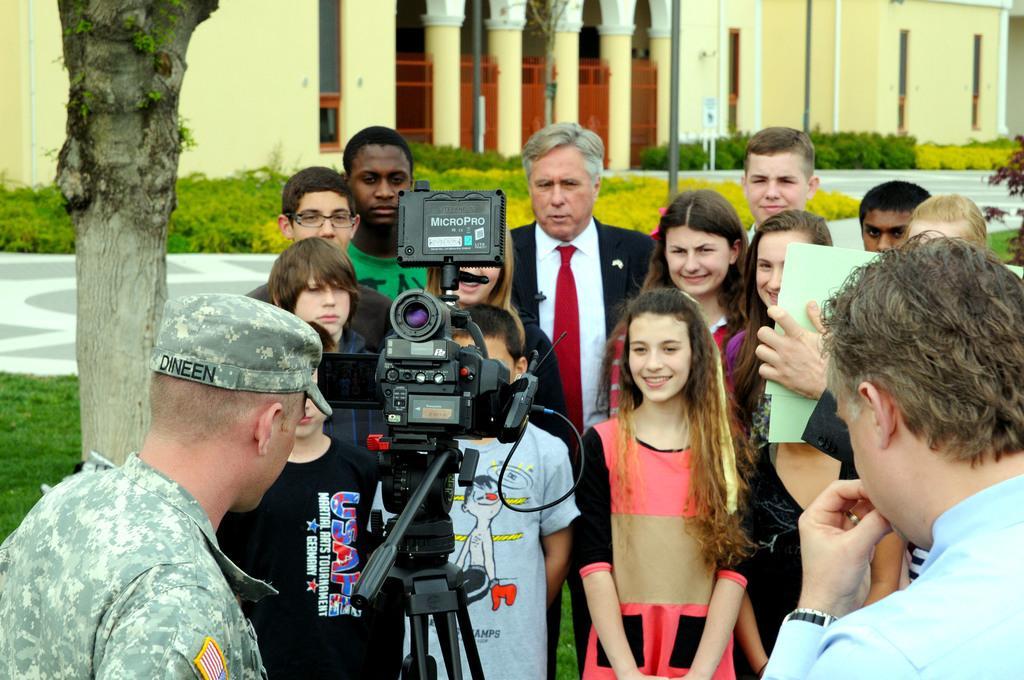How would you summarize this image in a sentence or two? In this picture we can see a group of people and a camera and in the background we can see a building, plants, tree trunk and some objects. 